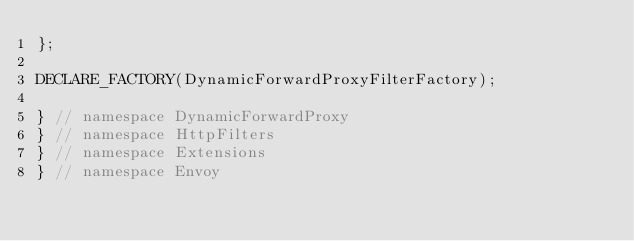<code> <loc_0><loc_0><loc_500><loc_500><_C_>};

DECLARE_FACTORY(DynamicForwardProxyFilterFactory);

} // namespace DynamicForwardProxy
} // namespace HttpFilters
} // namespace Extensions
} // namespace Envoy
</code> 